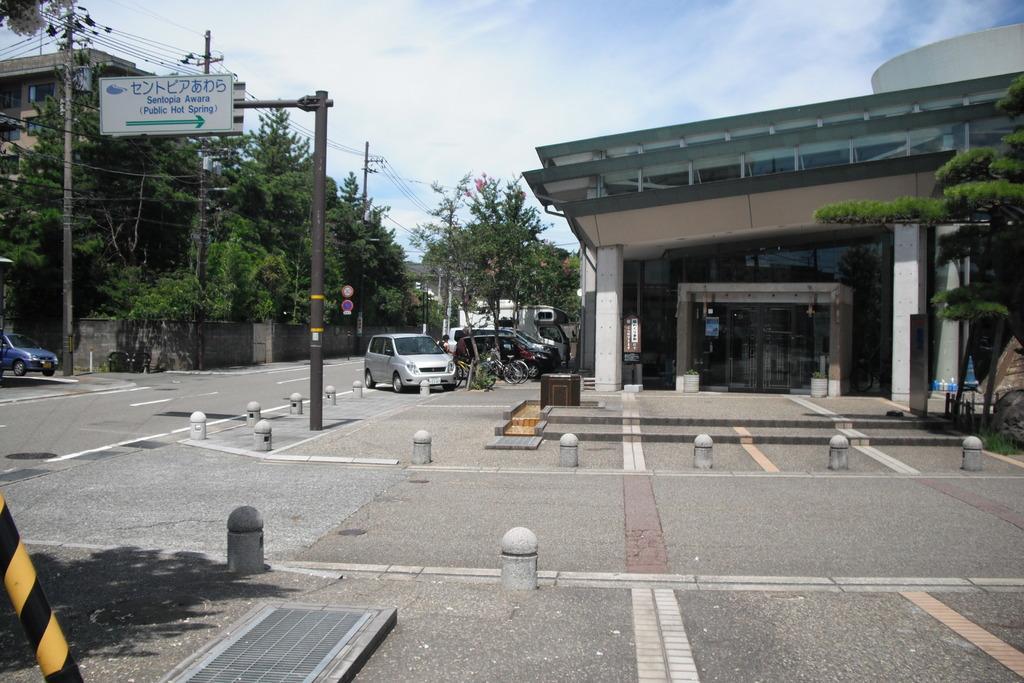Can you describe this image briefly? This picture shows trees and buildings and we see few cars and bicycles parked and sign boards to the pole and electrical poles and we see a blue cloudy sky. 